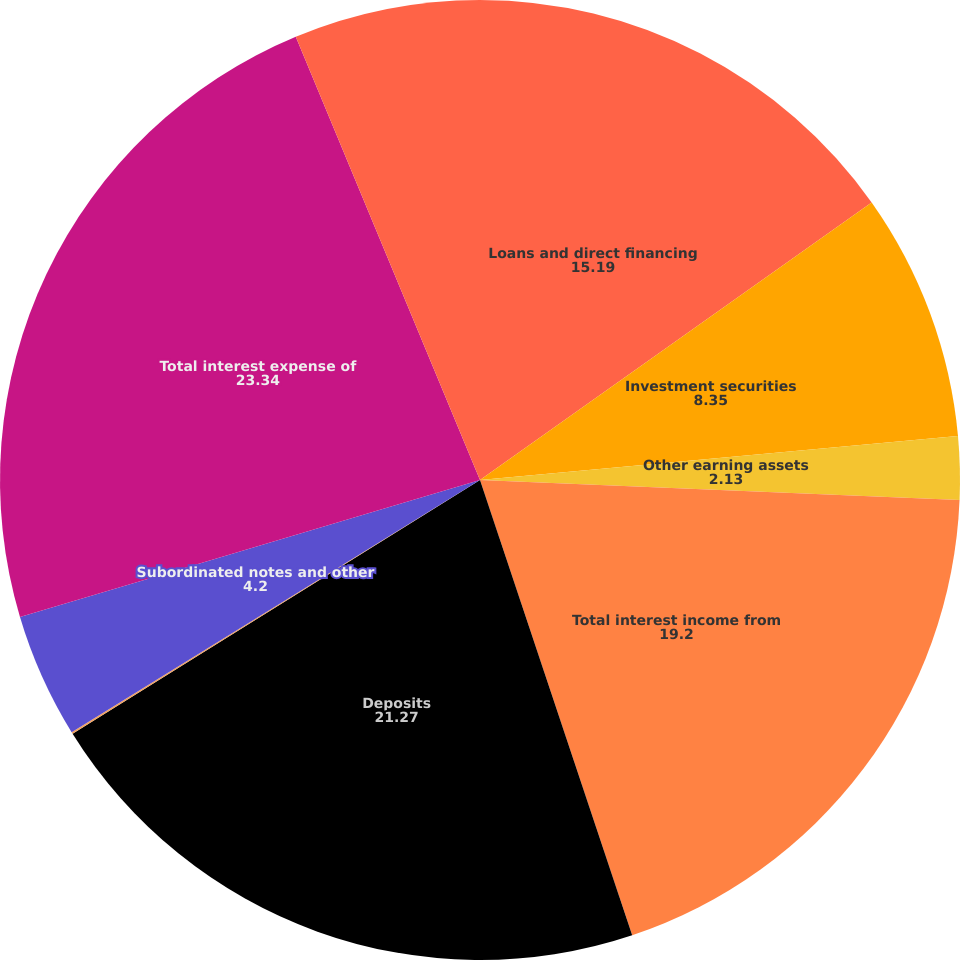<chart> <loc_0><loc_0><loc_500><loc_500><pie_chart><fcel>Loans and direct financing<fcel>Investment securities<fcel>Other earning assets<fcel>Total interest income from<fcel>Deposits<fcel>Short-term borrowings<fcel>Subordinated notes and other<fcel>Total interest expense of<fcel>Net interest income<nl><fcel>15.19%<fcel>8.35%<fcel>2.13%<fcel>19.2%<fcel>21.27%<fcel>0.06%<fcel>4.2%<fcel>23.34%<fcel>6.27%<nl></chart> 